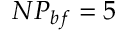Convert formula to latex. <formula><loc_0><loc_0><loc_500><loc_500>N P _ { b f } = 5</formula> 